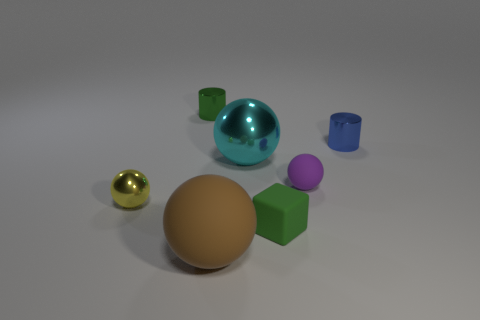Subtract all cyan balls. How many balls are left? 3 Subtract all small purple matte spheres. How many spheres are left? 3 Subtract all blue spheres. Subtract all brown blocks. How many spheres are left? 4 Add 3 small purple balls. How many objects exist? 10 Subtract all blocks. How many objects are left? 6 Add 4 tiny rubber spheres. How many tiny rubber spheres exist? 5 Subtract 0 purple cylinders. How many objects are left? 7 Subtract all tiny purple objects. Subtract all tiny brown metal cylinders. How many objects are left? 6 Add 5 tiny purple rubber spheres. How many tiny purple rubber spheres are left? 6 